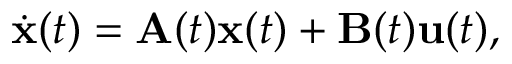Convert formula to latex. <formula><loc_0><loc_0><loc_500><loc_500>{ \dot { x } } ( t ) = A ( t ) x ( t ) + B ( t ) u ( t ) ,</formula> 